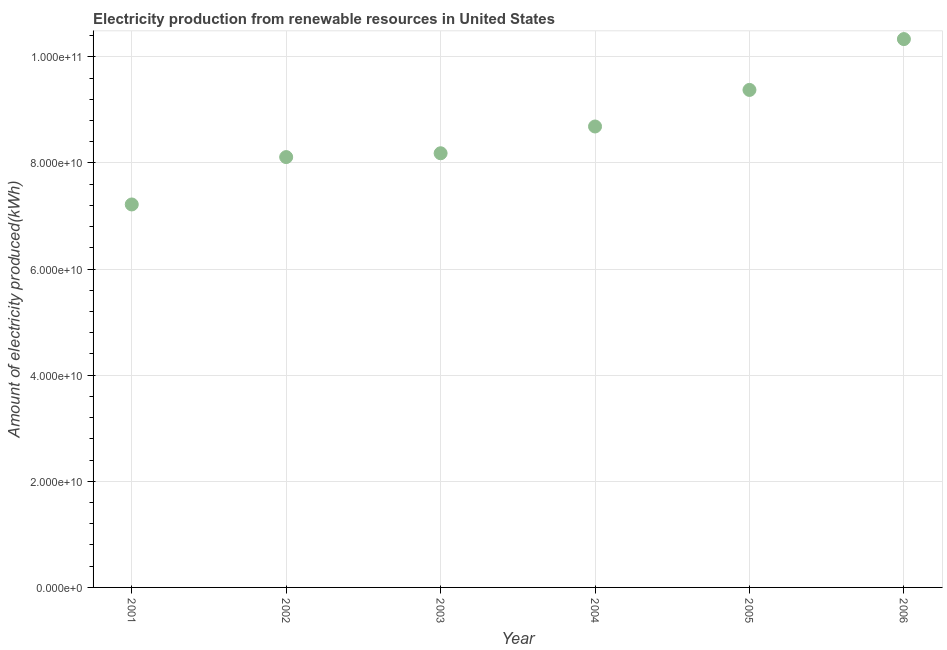What is the amount of electricity produced in 2002?
Your answer should be very brief. 8.11e+1. Across all years, what is the maximum amount of electricity produced?
Give a very brief answer. 1.03e+11. Across all years, what is the minimum amount of electricity produced?
Your answer should be compact. 7.22e+1. What is the sum of the amount of electricity produced?
Give a very brief answer. 5.19e+11. What is the difference between the amount of electricity produced in 2005 and 2006?
Your answer should be compact. -9.58e+09. What is the average amount of electricity produced per year?
Provide a succinct answer. 8.65e+1. What is the median amount of electricity produced?
Make the answer very short. 8.43e+1. In how many years, is the amount of electricity produced greater than 20000000000 kWh?
Keep it short and to the point. 6. Do a majority of the years between 2003 and 2002 (inclusive) have amount of electricity produced greater than 68000000000 kWh?
Give a very brief answer. No. What is the ratio of the amount of electricity produced in 2002 to that in 2005?
Provide a short and direct response. 0.87. Is the amount of electricity produced in 2002 less than that in 2003?
Make the answer very short. Yes. Is the difference between the amount of electricity produced in 2003 and 2006 greater than the difference between any two years?
Your response must be concise. No. What is the difference between the highest and the second highest amount of electricity produced?
Provide a short and direct response. 9.58e+09. Is the sum of the amount of electricity produced in 2002 and 2003 greater than the maximum amount of electricity produced across all years?
Offer a very short reply. Yes. What is the difference between the highest and the lowest amount of electricity produced?
Offer a very short reply. 3.12e+1. In how many years, is the amount of electricity produced greater than the average amount of electricity produced taken over all years?
Your answer should be compact. 3. How many dotlines are there?
Offer a terse response. 1. How many years are there in the graph?
Provide a short and direct response. 6. What is the title of the graph?
Offer a very short reply. Electricity production from renewable resources in United States. What is the label or title of the X-axis?
Your response must be concise. Year. What is the label or title of the Y-axis?
Your answer should be compact. Amount of electricity produced(kWh). What is the Amount of electricity produced(kWh) in 2001?
Provide a short and direct response. 7.22e+1. What is the Amount of electricity produced(kWh) in 2002?
Give a very brief answer. 8.11e+1. What is the Amount of electricity produced(kWh) in 2003?
Ensure brevity in your answer.  8.18e+1. What is the Amount of electricity produced(kWh) in 2004?
Offer a terse response. 8.69e+1. What is the Amount of electricity produced(kWh) in 2005?
Your response must be concise. 9.38e+1. What is the Amount of electricity produced(kWh) in 2006?
Keep it short and to the point. 1.03e+11. What is the difference between the Amount of electricity produced(kWh) in 2001 and 2002?
Provide a succinct answer. -8.93e+09. What is the difference between the Amount of electricity produced(kWh) in 2001 and 2003?
Give a very brief answer. -9.65e+09. What is the difference between the Amount of electricity produced(kWh) in 2001 and 2004?
Ensure brevity in your answer.  -1.47e+1. What is the difference between the Amount of electricity produced(kWh) in 2001 and 2005?
Offer a terse response. -2.16e+1. What is the difference between the Amount of electricity produced(kWh) in 2001 and 2006?
Your answer should be compact. -3.12e+1. What is the difference between the Amount of electricity produced(kWh) in 2002 and 2003?
Provide a short and direct response. -7.21e+08. What is the difference between the Amount of electricity produced(kWh) in 2002 and 2004?
Offer a very short reply. -5.77e+09. What is the difference between the Amount of electricity produced(kWh) in 2002 and 2005?
Make the answer very short. -1.27e+1. What is the difference between the Amount of electricity produced(kWh) in 2002 and 2006?
Your answer should be compact. -2.22e+1. What is the difference between the Amount of electricity produced(kWh) in 2003 and 2004?
Offer a very short reply. -5.04e+09. What is the difference between the Amount of electricity produced(kWh) in 2003 and 2005?
Your answer should be very brief. -1.19e+1. What is the difference between the Amount of electricity produced(kWh) in 2003 and 2006?
Give a very brief answer. -2.15e+1. What is the difference between the Amount of electricity produced(kWh) in 2004 and 2005?
Ensure brevity in your answer.  -6.89e+09. What is the difference between the Amount of electricity produced(kWh) in 2004 and 2006?
Offer a terse response. -1.65e+1. What is the difference between the Amount of electricity produced(kWh) in 2005 and 2006?
Make the answer very short. -9.58e+09. What is the ratio of the Amount of electricity produced(kWh) in 2001 to that in 2002?
Offer a terse response. 0.89. What is the ratio of the Amount of electricity produced(kWh) in 2001 to that in 2003?
Offer a very short reply. 0.88. What is the ratio of the Amount of electricity produced(kWh) in 2001 to that in 2004?
Offer a very short reply. 0.83. What is the ratio of the Amount of electricity produced(kWh) in 2001 to that in 2005?
Provide a succinct answer. 0.77. What is the ratio of the Amount of electricity produced(kWh) in 2001 to that in 2006?
Your answer should be compact. 0.7. What is the ratio of the Amount of electricity produced(kWh) in 2002 to that in 2003?
Keep it short and to the point. 0.99. What is the ratio of the Amount of electricity produced(kWh) in 2002 to that in 2004?
Make the answer very short. 0.93. What is the ratio of the Amount of electricity produced(kWh) in 2002 to that in 2005?
Ensure brevity in your answer.  0.86. What is the ratio of the Amount of electricity produced(kWh) in 2002 to that in 2006?
Offer a terse response. 0.79. What is the ratio of the Amount of electricity produced(kWh) in 2003 to that in 2004?
Your response must be concise. 0.94. What is the ratio of the Amount of electricity produced(kWh) in 2003 to that in 2005?
Offer a terse response. 0.87. What is the ratio of the Amount of electricity produced(kWh) in 2003 to that in 2006?
Offer a very short reply. 0.79. What is the ratio of the Amount of electricity produced(kWh) in 2004 to that in 2005?
Your response must be concise. 0.93. What is the ratio of the Amount of electricity produced(kWh) in 2004 to that in 2006?
Give a very brief answer. 0.84. What is the ratio of the Amount of electricity produced(kWh) in 2005 to that in 2006?
Ensure brevity in your answer.  0.91. 